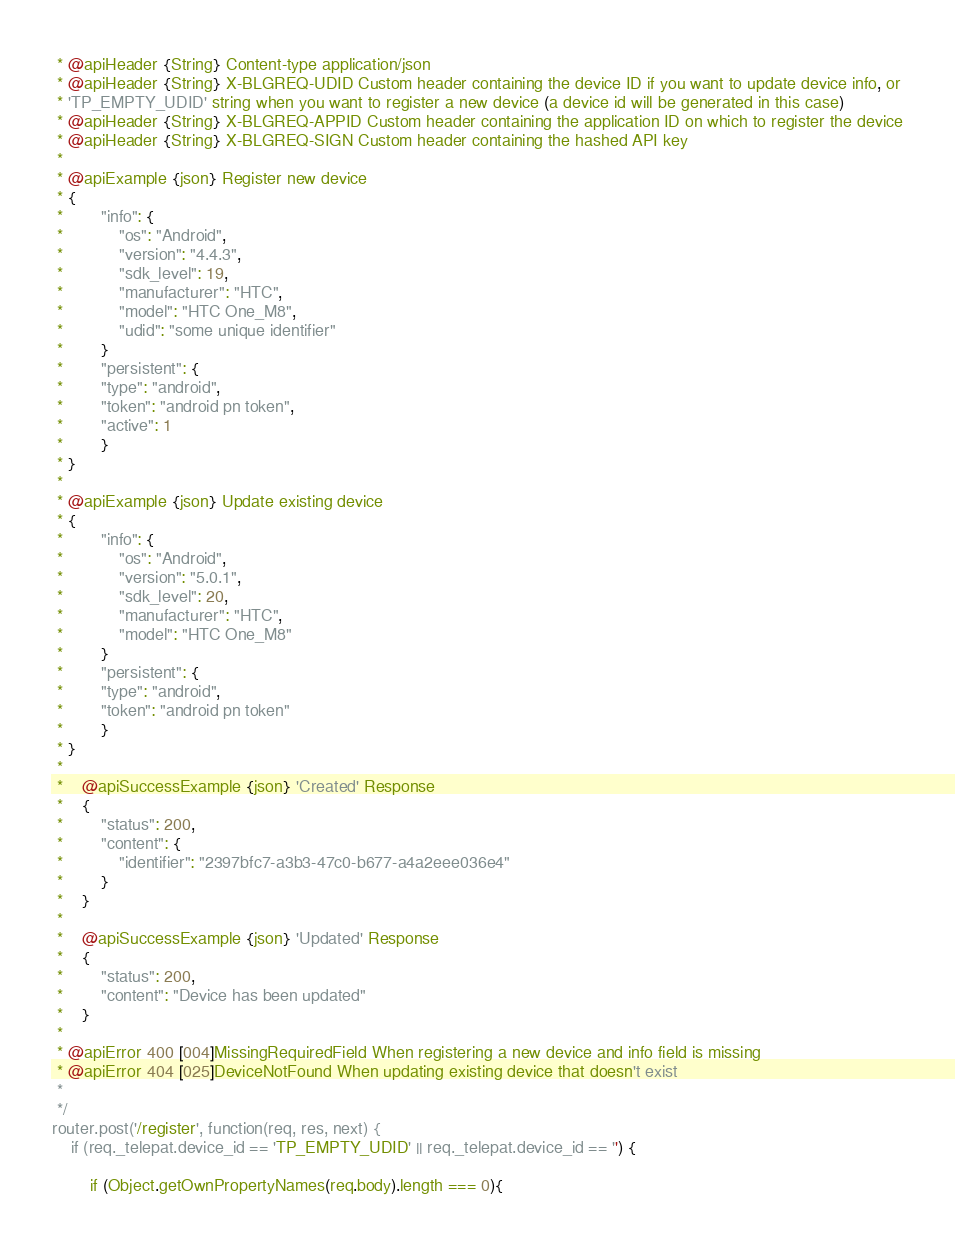<code> <loc_0><loc_0><loc_500><loc_500><_JavaScript_> * @apiHeader {String} Content-type application/json
 * @apiHeader {String} X-BLGREQ-UDID Custom header containing the device ID if you want to update device info, or
 * 'TP_EMPTY_UDID' string when you want to register a new device (a device id will be generated in this case)
 * @apiHeader {String} X-BLGREQ-APPID Custom header containing the application ID on which to register the device
 * @apiHeader {String} X-BLGREQ-SIGN Custom header containing the hashed API key
 *
 * @apiExample {json} Register new device
 * {
 * 		"info": {
 * 			"os": "Android",
 * 			"version": "4.4.3",
 * 			"sdk_level": 19,
 * 			"manufacturer": "HTC",
 * 			"model": "HTC One_M8",
 * 			"udid": "some unique identifier"
 * 		}
 * 		"persistent": {
 *   		"type": "android",
 *   		"token": "android pn token",
 *   		"active": 1
 * 		}
 * }
 *
 * @apiExample {json} Update existing device
 * {
 * 		"info": {
 * 			"os": "Android",
 * 			"version": "5.0.1",
 * 			"sdk_level": 20,
 * 			"manufacturer": "HTC",
 * 			"model": "HTC One_M8"
 * 		}
 * 		"persistent": {
 *   		"type": "android",
 *   		"token": "android pn token"
 * 		}
 * }
 *
 * 	@apiSuccessExample {json} 'Created' Response
 * 	{
 * 		"status": 200,
 * 		"content": {
 * 			"identifier": "2397bfc7-a3b3-47c0-b677-a4a2eee036e4"
 * 		}
 * 	}
 *
 * 	@apiSuccessExample {json} 'Updated' Response
 * 	{
 * 		"status": 200,
 * 		"content": "Device has been updated"
 * 	}
 *
 * @apiError 400 [004]MissingRequiredField When registering a new device and info field is missing
 * @apiError 404 [025]DeviceNotFound When updating existing device that doesn't exist
 *
 */
router.post('/register', function(req, res, next) {
	if (req._telepat.device_id == 'TP_EMPTY_UDID' || req._telepat.device_id == '') {

		if (Object.getOwnPropertyNames(req.body).length === 0){</code> 